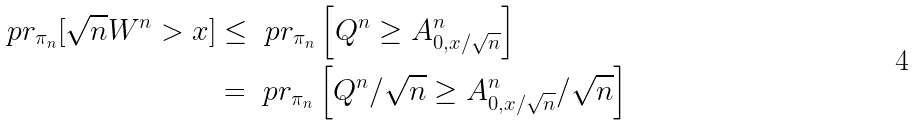<formula> <loc_0><loc_0><loc_500><loc_500>\ p r _ { \pi _ { n } } [ \sqrt { n } W ^ { n } > x ] & \leq \ p r _ { \pi _ { n } } \left [ Q ^ { n } \geq A ^ { n } _ { 0 , x / \sqrt { n } } \right ] \\ & = \ p r _ { \pi _ { n } } \left [ Q ^ { n } / \sqrt { n } \geq A ^ { n } _ { 0 , x / \sqrt { n } } / \sqrt { n } \right ]</formula> 